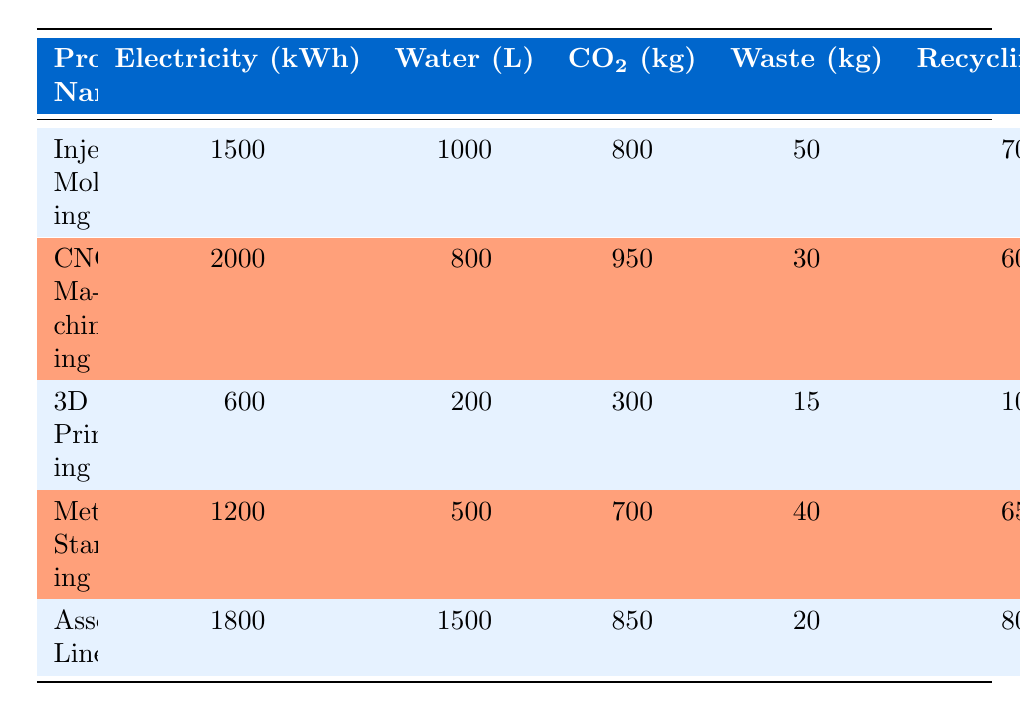What's the CO2 emissions for CNC Machining? The table lists the CO2 emissions for each process. Looking at the row for CNC Machining, it shows CO2 emissions of 950 kg.
Answer: 950 kg What is the electricity consumption of 3D Printing? In the table, the electricity consumption is specified for each process. For 3D Printing, it is recorded as 600 kWh.
Answer: 600 kWh Which process has the highest water usage? The water usage amounts for each process are visible in the table. By comparing the values, Assembly Line has the highest water usage at 1500 liters.
Answer: 1500 liters Is the recycling rate for Injection Molding greater than 60%? In the table, the recycling rate for Injection Molding is listed as 70%. Since 70% is greater than 60%, the statement is true.
Answer: Yes What is the total waste generated across all processes? To find the total waste generated, we add the waste values from all processes: 50 (Injection Molding) + 30 (CNC Machining) + 15 (3D Printing) + 40 (Metal Stamping) + 20 (Assembly Line) = 155 kg.
Answer: 155 kg Which process produces the least CO2 emissions? The table lists CO2 emissions for each process, requiring a comparison to determine the least. 3D Printing has the lowest CO2 emissions at 300 kg.
Answer: 300 kg If we average the electricity consumption for all processes, what is the result? To find the average electricity consumption, sum the values: 1500 + 2000 + 600 + 1200 + 1800 = 8100 kWh. There are 5 processes, so the average is 8100 kWh / 5 = 1620 kWh.
Answer: 1620 kWh What process has the lowest recycling rate? The recycling rates for the processes are compared from the table. 3D Printing has the lowest recycling rate at 10%.
Answer: 10% Does Metal Stamping use more water than Injection Molding? The table shows water usage for both processes: Metal Stamping uses 500 liters and Injection Molding uses 1000 liters. Since 500 is less than 1000, the statement is false.
Answer: No 